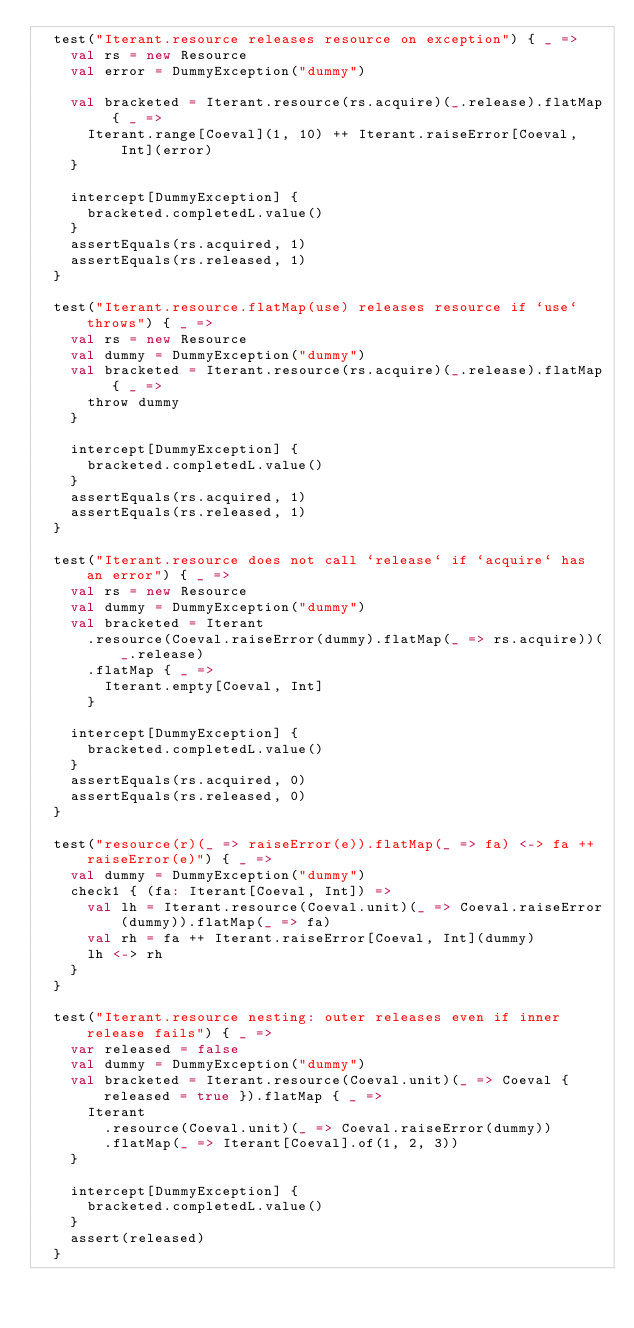Convert code to text. <code><loc_0><loc_0><loc_500><loc_500><_Scala_>  test("Iterant.resource releases resource on exception") { _ =>
    val rs = new Resource
    val error = DummyException("dummy")

    val bracketed = Iterant.resource(rs.acquire)(_.release).flatMap { _ =>
      Iterant.range[Coeval](1, 10) ++ Iterant.raiseError[Coeval, Int](error)
    }

    intercept[DummyException] {
      bracketed.completedL.value()
    }
    assertEquals(rs.acquired, 1)
    assertEquals(rs.released, 1)
  }

  test("Iterant.resource.flatMap(use) releases resource if `use` throws") { _ =>
    val rs = new Resource
    val dummy = DummyException("dummy")
    val bracketed = Iterant.resource(rs.acquire)(_.release).flatMap { _ =>
      throw dummy
    }

    intercept[DummyException] {
      bracketed.completedL.value()
    }
    assertEquals(rs.acquired, 1)
    assertEquals(rs.released, 1)
  }

  test("Iterant.resource does not call `release` if `acquire` has an error") { _ =>
    val rs = new Resource
    val dummy = DummyException("dummy")
    val bracketed = Iterant
      .resource(Coeval.raiseError(dummy).flatMap(_ => rs.acquire))(_.release)
      .flatMap { _ =>
        Iterant.empty[Coeval, Int]
      }

    intercept[DummyException] {
      bracketed.completedL.value()
    }
    assertEquals(rs.acquired, 0)
    assertEquals(rs.released, 0)
  }

  test("resource(r)(_ => raiseError(e)).flatMap(_ => fa) <-> fa ++ raiseError(e)") { _ =>
    val dummy = DummyException("dummy")
    check1 { (fa: Iterant[Coeval, Int]) =>
      val lh = Iterant.resource(Coeval.unit)(_ => Coeval.raiseError(dummy)).flatMap(_ => fa)
      val rh = fa ++ Iterant.raiseError[Coeval, Int](dummy)
      lh <-> rh
    }
  }

  test("Iterant.resource nesting: outer releases even if inner release fails") { _ =>
    var released = false
    val dummy = DummyException("dummy")
    val bracketed = Iterant.resource(Coeval.unit)(_ => Coeval { released = true }).flatMap { _ =>
      Iterant
        .resource(Coeval.unit)(_ => Coeval.raiseError(dummy))
        .flatMap(_ => Iterant[Coeval].of(1, 2, 3))
    }

    intercept[DummyException] {
      bracketed.completedL.value()
    }
    assert(released)
  }
</code> 